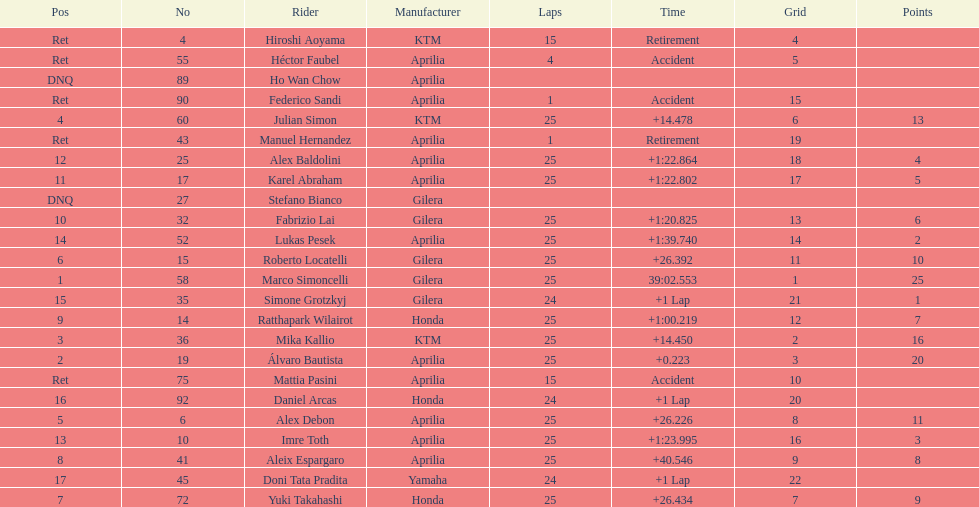Who perfomed the most number of laps, marco simoncelli or hiroshi aoyama? Marco Simoncelli. 